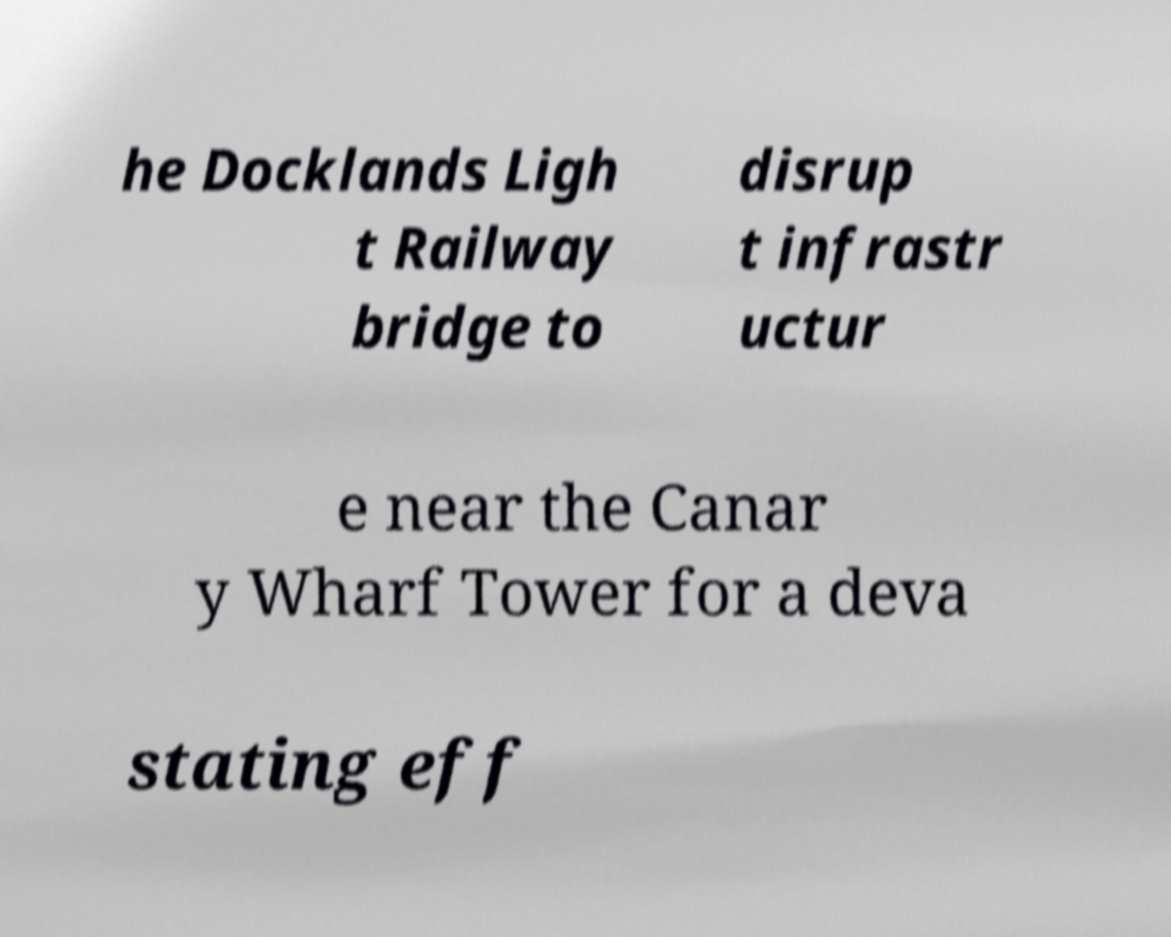I need the written content from this picture converted into text. Can you do that? he Docklands Ligh t Railway bridge to disrup t infrastr uctur e near the Canar y Wharf Tower for a deva stating eff 